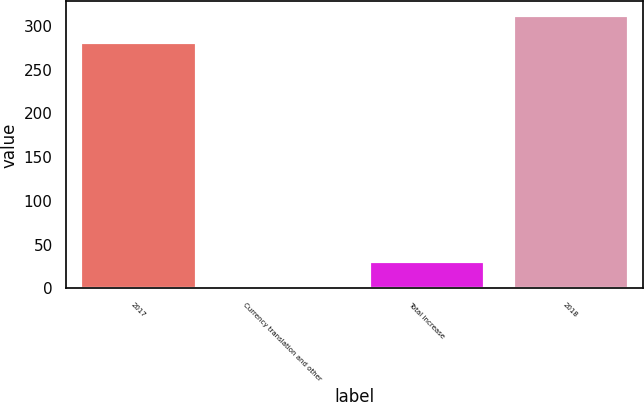Convert chart. <chart><loc_0><loc_0><loc_500><loc_500><bar_chart><fcel>2017<fcel>Currency translation and other<fcel>Total increase<fcel>2018<nl><fcel>281.5<fcel>0.6<fcel>31.62<fcel>312.52<nl></chart> 